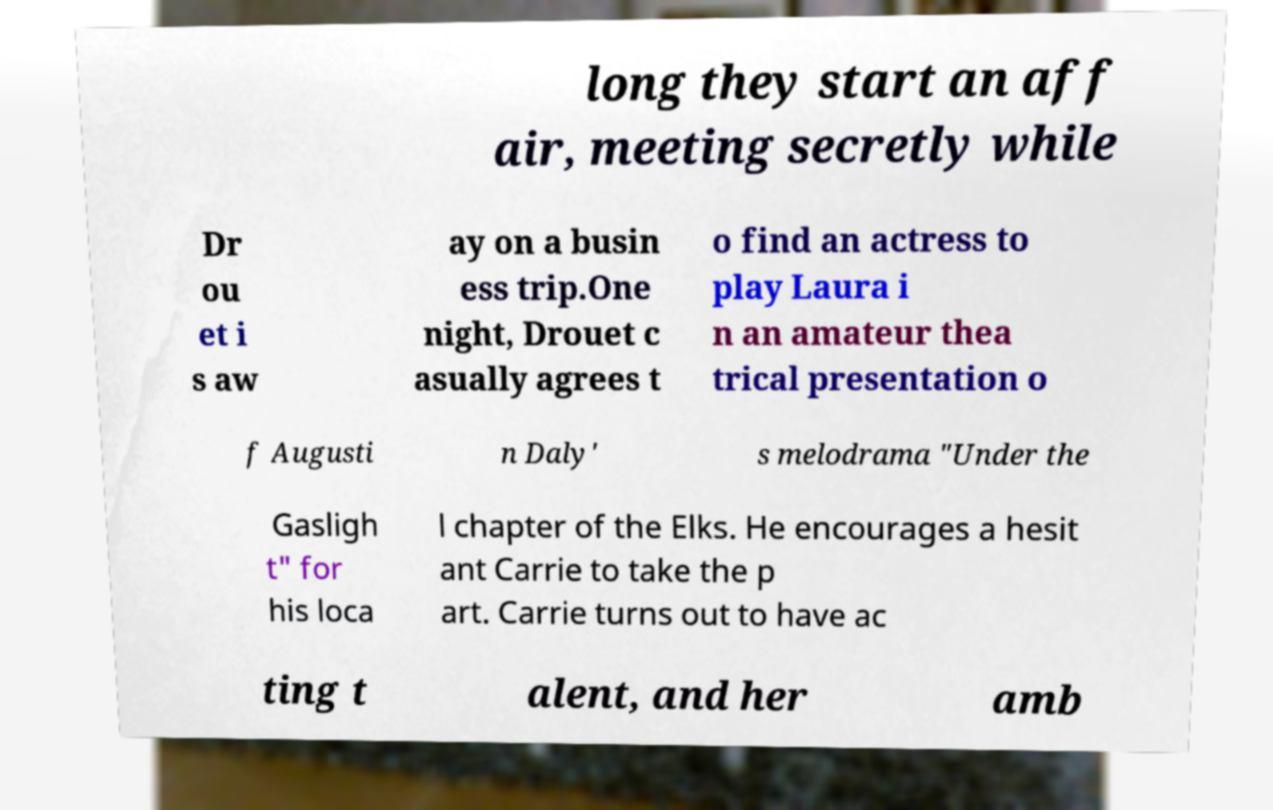I need the written content from this picture converted into text. Can you do that? long they start an aff air, meeting secretly while Dr ou et i s aw ay on a busin ess trip.One night, Drouet c asually agrees t o find an actress to play Laura i n an amateur thea trical presentation o f Augusti n Daly' s melodrama "Under the Gasligh t" for his loca l chapter of the Elks. He encourages a hesit ant Carrie to take the p art. Carrie turns out to have ac ting t alent, and her amb 